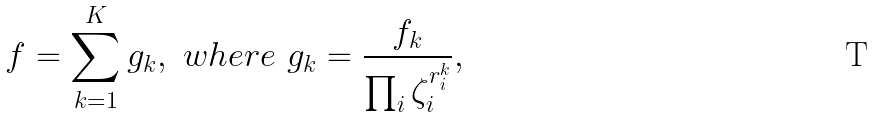<formula> <loc_0><loc_0><loc_500><loc_500>f = \sum _ { k = 1 } ^ { K } g _ { k } , \ w h e r e \ g _ { k } = \frac { f _ { k } } { \prod _ { i } \zeta _ { i } ^ { r _ { i } ^ { k } } } ,</formula> 